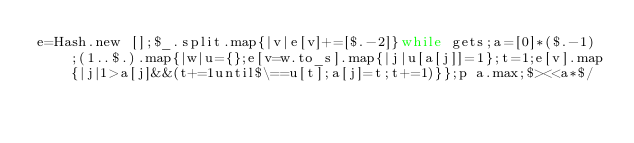Convert code to text. <code><loc_0><loc_0><loc_500><loc_500><_Ruby_>e=Hash.new [];$_.split.map{|v|e[v]+=[$.-2]}while gets;a=[0]*($.-1);(1..$.).map{|w|u={};e[v=w.to_s].map{|j|u[a[j]]=1};t=1;e[v].map{|j|1>a[j]&&(t+=1until$\==u[t];a[j]=t;t+=1)}};p a.max;$><<a*$/</code> 